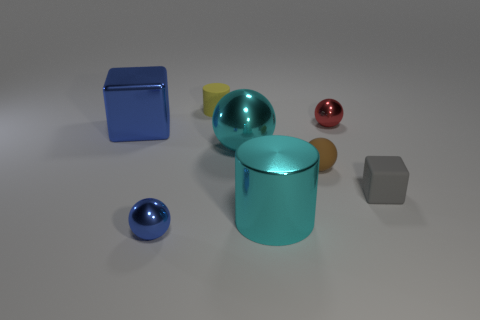There is a metal ball that is to the left of the yellow cylinder; what color is it?
Ensure brevity in your answer.  Blue. What number of tiny rubber balls are the same color as the big cube?
Give a very brief answer. 0. How many blue metal objects are both to the right of the big block and behind the shiny cylinder?
Keep it short and to the point. 0. What shape is the brown rubber object that is the same size as the gray rubber thing?
Offer a terse response. Sphere. The brown ball is what size?
Your response must be concise. Small. There is a block to the left of the tiny object that is behind the tiny red ball right of the blue ball; what is it made of?
Make the answer very short. Metal. What is the color of the cylinder that is made of the same material as the red thing?
Your answer should be very brief. Cyan. There is a tiny metal object in front of the big cyan metal thing that is to the right of the large cyan metal sphere; how many shiny cubes are behind it?
Offer a terse response. 1. What is the material of the small sphere that is the same color as the big cube?
Your answer should be very brief. Metal. Is there anything else that has the same shape as the tiny blue metallic thing?
Keep it short and to the point. Yes. 